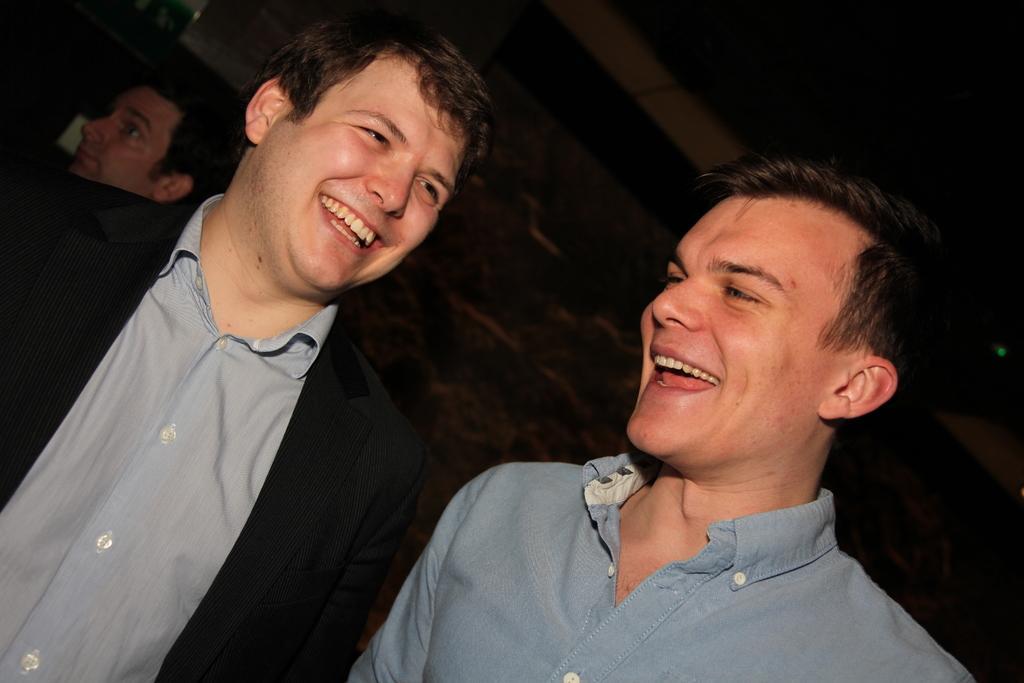Can you describe this image briefly? This picture describes about group of people, in the middle of the image we can see two men, they both are smiling. 